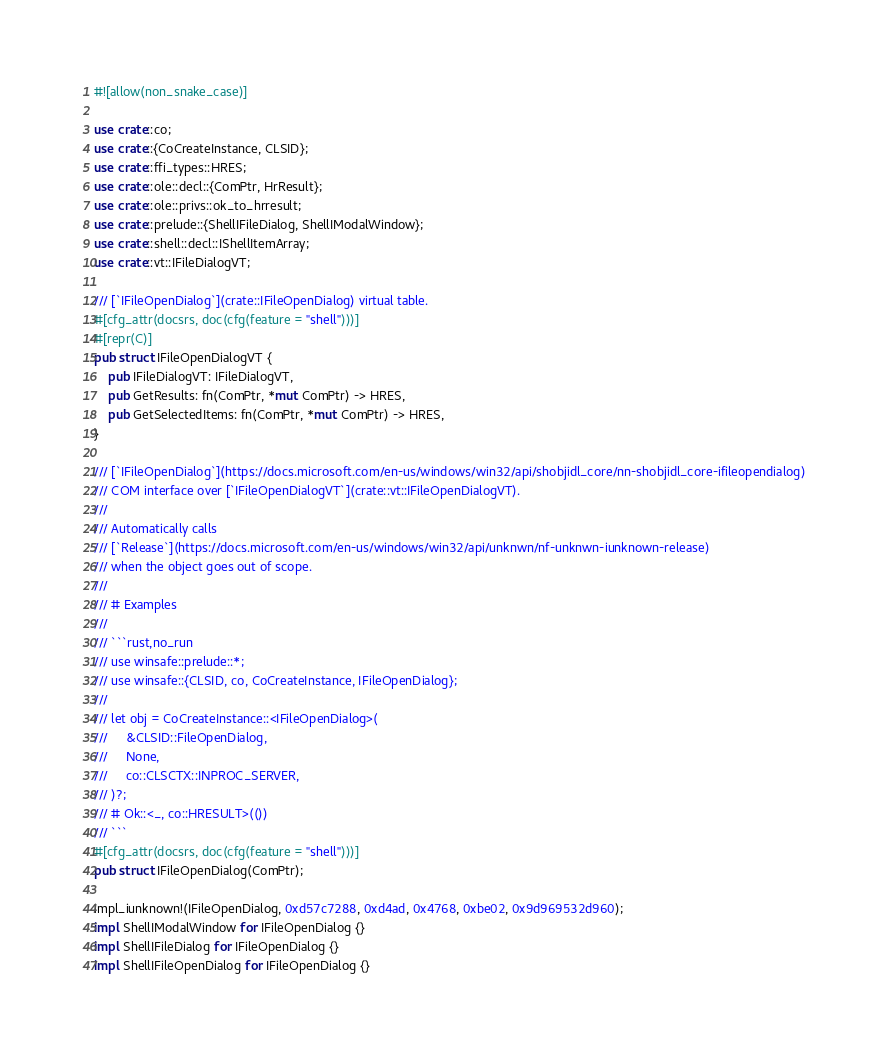<code> <loc_0><loc_0><loc_500><loc_500><_Rust_>#![allow(non_snake_case)]

use crate::co;
use crate::{CoCreateInstance, CLSID};
use crate::ffi_types::HRES;
use crate::ole::decl::{ComPtr, HrResult};
use crate::ole::privs::ok_to_hrresult;
use crate::prelude::{ShellIFileDialog, ShellIModalWindow};
use crate::shell::decl::IShellItemArray;
use crate::vt::IFileDialogVT;

/// [`IFileOpenDialog`](crate::IFileOpenDialog) virtual table.
#[cfg_attr(docsrs, doc(cfg(feature = "shell")))]
#[repr(C)]
pub struct IFileOpenDialogVT {
	pub IFileDialogVT: IFileDialogVT,
	pub GetResults: fn(ComPtr, *mut ComPtr) -> HRES,
	pub GetSelectedItems: fn(ComPtr, *mut ComPtr) -> HRES,
}

/// [`IFileOpenDialog`](https://docs.microsoft.com/en-us/windows/win32/api/shobjidl_core/nn-shobjidl_core-ifileopendialog)
/// COM interface over [`IFileOpenDialogVT`](crate::vt::IFileOpenDialogVT).
///
/// Automatically calls
/// [`Release`](https://docs.microsoft.com/en-us/windows/win32/api/unknwn/nf-unknwn-iunknown-release)
/// when the object goes out of scope.
///
/// # Examples
///
/// ```rust,no_run
/// use winsafe::prelude::*;
/// use winsafe::{CLSID, co, CoCreateInstance, IFileOpenDialog};
///
/// let obj = CoCreateInstance::<IFileOpenDialog>(
///     &CLSID::FileOpenDialog,
///     None,
///     co::CLSCTX::INPROC_SERVER,
/// )?;
/// # Ok::<_, co::HRESULT>(())
/// ```
#[cfg_attr(docsrs, doc(cfg(feature = "shell")))]
pub struct IFileOpenDialog(ComPtr);

impl_iunknown!(IFileOpenDialog, 0xd57c7288, 0xd4ad, 0x4768, 0xbe02, 0x9d969532d960);
impl ShellIModalWindow for IFileOpenDialog {}
impl ShellIFileDialog for IFileOpenDialog {}
impl ShellIFileOpenDialog for IFileOpenDialog {}
</code> 